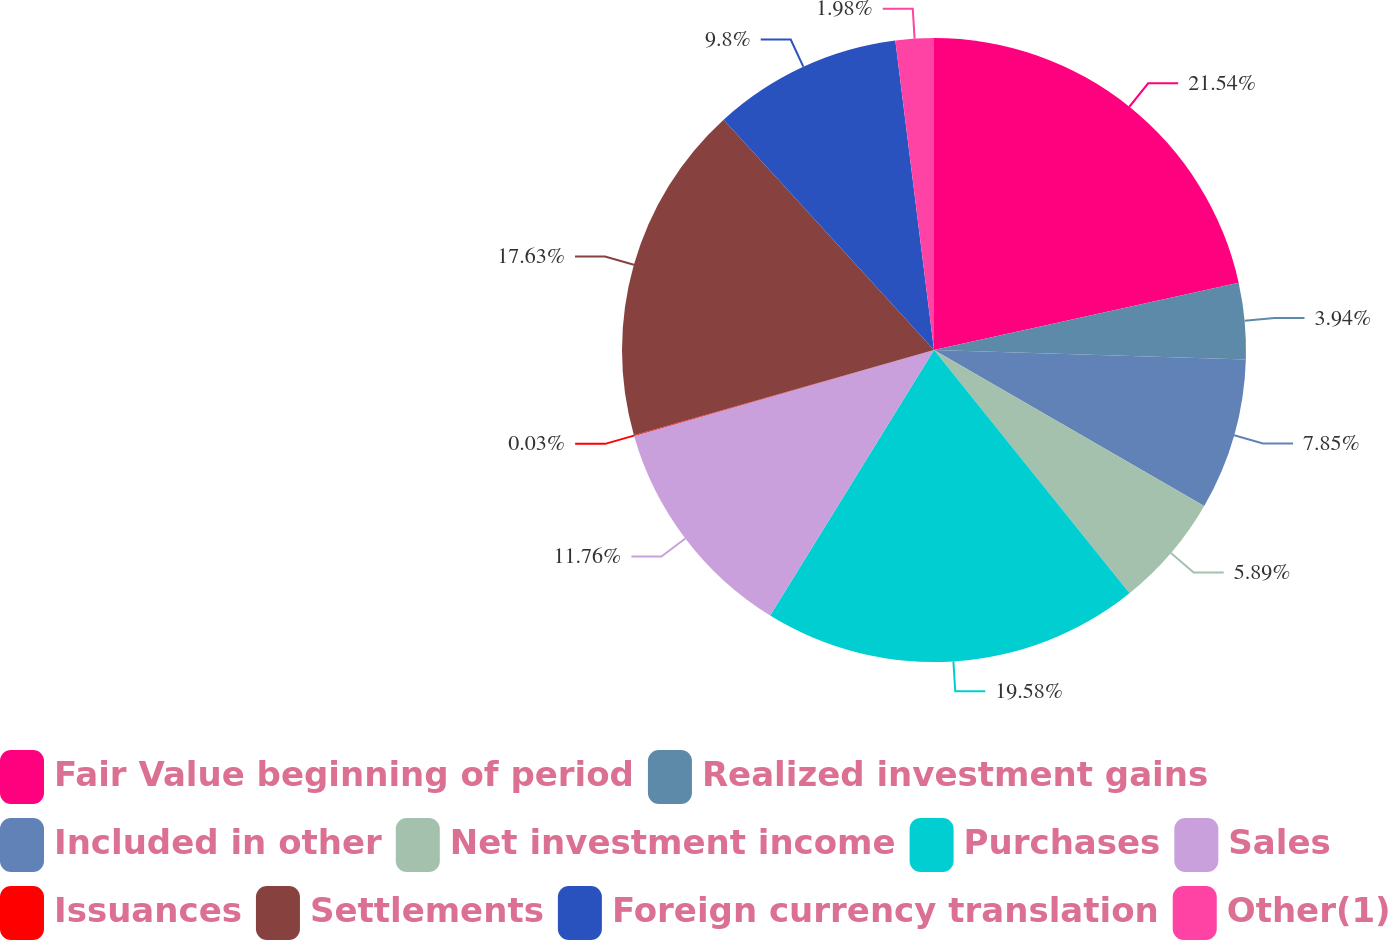<chart> <loc_0><loc_0><loc_500><loc_500><pie_chart><fcel>Fair Value beginning of period<fcel>Realized investment gains<fcel>Included in other<fcel>Net investment income<fcel>Purchases<fcel>Sales<fcel>Issuances<fcel>Settlements<fcel>Foreign currency translation<fcel>Other(1)<nl><fcel>21.54%<fcel>3.94%<fcel>7.85%<fcel>5.89%<fcel>19.58%<fcel>11.76%<fcel>0.03%<fcel>17.63%<fcel>9.8%<fcel>1.98%<nl></chart> 